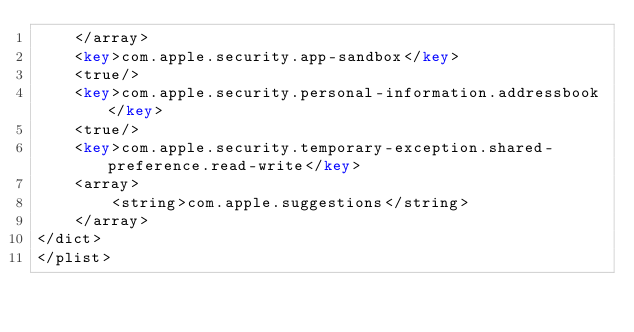Convert code to text. <code><loc_0><loc_0><loc_500><loc_500><_XML_>	</array>
	<key>com.apple.security.app-sandbox</key>
	<true/>
	<key>com.apple.security.personal-information.addressbook</key>
	<true/>
	<key>com.apple.security.temporary-exception.shared-preference.read-write</key>
	<array>
		<string>com.apple.suggestions</string>
	</array>
</dict>
</plist>
</code> 